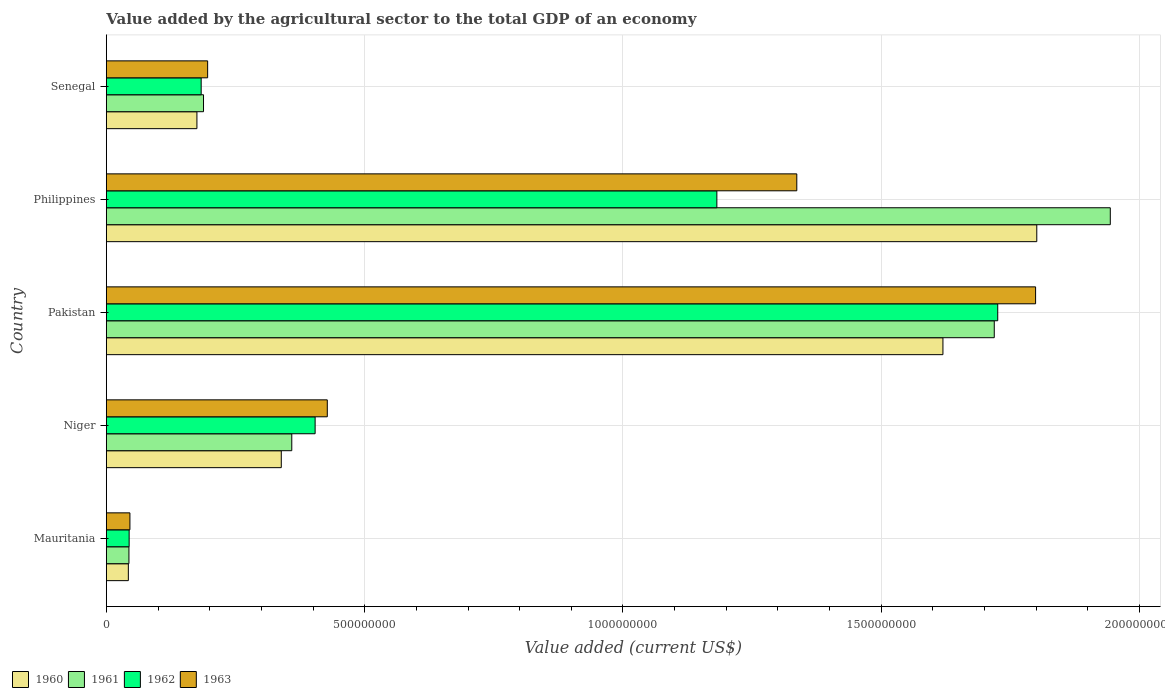How many groups of bars are there?
Provide a short and direct response. 5. Are the number of bars per tick equal to the number of legend labels?
Provide a succinct answer. Yes. What is the value added by the agricultural sector to the total GDP in 1963 in Philippines?
Your response must be concise. 1.34e+09. Across all countries, what is the maximum value added by the agricultural sector to the total GDP in 1960?
Offer a very short reply. 1.80e+09. Across all countries, what is the minimum value added by the agricultural sector to the total GDP in 1960?
Give a very brief answer. 4.26e+07. In which country was the value added by the agricultural sector to the total GDP in 1960 maximum?
Make the answer very short. Philippines. In which country was the value added by the agricultural sector to the total GDP in 1963 minimum?
Provide a short and direct response. Mauritania. What is the total value added by the agricultural sector to the total GDP in 1960 in the graph?
Offer a terse response. 3.98e+09. What is the difference between the value added by the agricultural sector to the total GDP in 1963 in Mauritania and that in Niger?
Provide a succinct answer. -3.82e+08. What is the difference between the value added by the agricultural sector to the total GDP in 1962 in Mauritania and the value added by the agricultural sector to the total GDP in 1963 in Pakistan?
Offer a very short reply. -1.75e+09. What is the average value added by the agricultural sector to the total GDP in 1962 per country?
Offer a very short reply. 7.08e+08. What is the difference between the value added by the agricultural sector to the total GDP in 1960 and value added by the agricultural sector to the total GDP in 1963 in Pakistan?
Keep it short and to the point. -1.79e+08. What is the ratio of the value added by the agricultural sector to the total GDP in 1962 in Mauritania to that in Senegal?
Offer a very short reply. 0.24. What is the difference between the highest and the second highest value added by the agricultural sector to the total GDP in 1961?
Provide a succinct answer. 2.25e+08. What is the difference between the highest and the lowest value added by the agricultural sector to the total GDP in 1960?
Keep it short and to the point. 1.76e+09. In how many countries, is the value added by the agricultural sector to the total GDP in 1960 greater than the average value added by the agricultural sector to the total GDP in 1960 taken over all countries?
Give a very brief answer. 2. Is it the case that in every country, the sum of the value added by the agricultural sector to the total GDP in 1962 and value added by the agricultural sector to the total GDP in 1961 is greater than the sum of value added by the agricultural sector to the total GDP in 1960 and value added by the agricultural sector to the total GDP in 1963?
Make the answer very short. No. Is it the case that in every country, the sum of the value added by the agricultural sector to the total GDP in 1960 and value added by the agricultural sector to the total GDP in 1963 is greater than the value added by the agricultural sector to the total GDP in 1962?
Keep it short and to the point. Yes. How many bars are there?
Your answer should be compact. 20. Does the graph contain any zero values?
Make the answer very short. No. Where does the legend appear in the graph?
Offer a very short reply. Bottom left. How are the legend labels stacked?
Make the answer very short. Horizontal. What is the title of the graph?
Your response must be concise. Value added by the agricultural sector to the total GDP of an economy. Does "2007" appear as one of the legend labels in the graph?
Offer a terse response. No. What is the label or title of the X-axis?
Your answer should be compact. Value added (current US$). What is the label or title of the Y-axis?
Your answer should be compact. Country. What is the Value added (current US$) of 1960 in Mauritania?
Provide a succinct answer. 4.26e+07. What is the Value added (current US$) in 1961 in Mauritania?
Provide a succinct answer. 4.37e+07. What is the Value added (current US$) of 1962 in Mauritania?
Your response must be concise. 4.41e+07. What is the Value added (current US$) in 1963 in Mauritania?
Keep it short and to the point. 4.57e+07. What is the Value added (current US$) of 1960 in Niger?
Provide a short and direct response. 3.39e+08. What is the Value added (current US$) in 1961 in Niger?
Your answer should be compact. 3.59e+08. What is the Value added (current US$) in 1962 in Niger?
Ensure brevity in your answer.  4.04e+08. What is the Value added (current US$) of 1963 in Niger?
Your answer should be compact. 4.28e+08. What is the Value added (current US$) of 1960 in Pakistan?
Offer a very short reply. 1.62e+09. What is the Value added (current US$) of 1961 in Pakistan?
Provide a short and direct response. 1.72e+09. What is the Value added (current US$) of 1962 in Pakistan?
Your answer should be very brief. 1.73e+09. What is the Value added (current US$) in 1963 in Pakistan?
Give a very brief answer. 1.80e+09. What is the Value added (current US$) in 1960 in Philippines?
Make the answer very short. 1.80e+09. What is the Value added (current US$) in 1961 in Philippines?
Your answer should be compact. 1.94e+09. What is the Value added (current US$) of 1962 in Philippines?
Make the answer very short. 1.18e+09. What is the Value added (current US$) of 1963 in Philippines?
Give a very brief answer. 1.34e+09. What is the Value added (current US$) in 1960 in Senegal?
Offer a terse response. 1.75e+08. What is the Value added (current US$) of 1961 in Senegal?
Ensure brevity in your answer.  1.88e+08. What is the Value added (current US$) of 1962 in Senegal?
Provide a short and direct response. 1.84e+08. What is the Value added (current US$) in 1963 in Senegal?
Give a very brief answer. 1.96e+08. Across all countries, what is the maximum Value added (current US$) of 1960?
Provide a short and direct response. 1.80e+09. Across all countries, what is the maximum Value added (current US$) in 1961?
Your response must be concise. 1.94e+09. Across all countries, what is the maximum Value added (current US$) in 1962?
Offer a terse response. 1.73e+09. Across all countries, what is the maximum Value added (current US$) in 1963?
Your answer should be very brief. 1.80e+09. Across all countries, what is the minimum Value added (current US$) in 1960?
Your answer should be compact. 4.26e+07. Across all countries, what is the minimum Value added (current US$) of 1961?
Ensure brevity in your answer.  4.37e+07. Across all countries, what is the minimum Value added (current US$) in 1962?
Provide a short and direct response. 4.41e+07. Across all countries, what is the minimum Value added (current US$) in 1963?
Give a very brief answer. 4.57e+07. What is the total Value added (current US$) of 1960 in the graph?
Provide a short and direct response. 3.98e+09. What is the total Value added (current US$) of 1961 in the graph?
Your answer should be very brief. 4.25e+09. What is the total Value added (current US$) of 1962 in the graph?
Your response must be concise. 3.54e+09. What is the total Value added (current US$) of 1963 in the graph?
Make the answer very short. 3.80e+09. What is the difference between the Value added (current US$) in 1960 in Mauritania and that in Niger?
Your response must be concise. -2.96e+08. What is the difference between the Value added (current US$) in 1961 in Mauritania and that in Niger?
Ensure brevity in your answer.  -3.15e+08. What is the difference between the Value added (current US$) in 1962 in Mauritania and that in Niger?
Keep it short and to the point. -3.60e+08. What is the difference between the Value added (current US$) of 1963 in Mauritania and that in Niger?
Give a very brief answer. -3.82e+08. What is the difference between the Value added (current US$) of 1960 in Mauritania and that in Pakistan?
Keep it short and to the point. -1.58e+09. What is the difference between the Value added (current US$) in 1961 in Mauritania and that in Pakistan?
Your response must be concise. -1.67e+09. What is the difference between the Value added (current US$) of 1962 in Mauritania and that in Pakistan?
Your response must be concise. -1.68e+09. What is the difference between the Value added (current US$) in 1963 in Mauritania and that in Pakistan?
Your answer should be compact. -1.75e+09. What is the difference between the Value added (current US$) of 1960 in Mauritania and that in Philippines?
Make the answer very short. -1.76e+09. What is the difference between the Value added (current US$) in 1961 in Mauritania and that in Philippines?
Keep it short and to the point. -1.90e+09. What is the difference between the Value added (current US$) in 1962 in Mauritania and that in Philippines?
Ensure brevity in your answer.  -1.14e+09. What is the difference between the Value added (current US$) in 1963 in Mauritania and that in Philippines?
Your answer should be compact. -1.29e+09. What is the difference between the Value added (current US$) of 1960 in Mauritania and that in Senegal?
Ensure brevity in your answer.  -1.33e+08. What is the difference between the Value added (current US$) of 1961 in Mauritania and that in Senegal?
Ensure brevity in your answer.  -1.44e+08. What is the difference between the Value added (current US$) in 1962 in Mauritania and that in Senegal?
Ensure brevity in your answer.  -1.39e+08. What is the difference between the Value added (current US$) of 1963 in Mauritania and that in Senegal?
Give a very brief answer. -1.50e+08. What is the difference between the Value added (current US$) in 1960 in Niger and that in Pakistan?
Offer a very short reply. -1.28e+09. What is the difference between the Value added (current US$) in 1961 in Niger and that in Pakistan?
Make the answer very short. -1.36e+09. What is the difference between the Value added (current US$) in 1962 in Niger and that in Pakistan?
Provide a succinct answer. -1.32e+09. What is the difference between the Value added (current US$) in 1963 in Niger and that in Pakistan?
Offer a very short reply. -1.37e+09. What is the difference between the Value added (current US$) of 1960 in Niger and that in Philippines?
Your answer should be compact. -1.46e+09. What is the difference between the Value added (current US$) in 1961 in Niger and that in Philippines?
Your answer should be compact. -1.58e+09. What is the difference between the Value added (current US$) in 1962 in Niger and that in Philippines?
Offer a terse response. -7.78e+08. What is the difference between the Value added (current US$) in 1963 in Niger and that in Philippines?
Give a very brief answer. -9.09e+08. What is the difference between the Value added (current US$) in 1960 in Niger and that in Senegal?
Offer a very short reply. 1.63e+08. What is the difference between the Value added (current US$) of 1961 in Niger and that in Senegal?
Your response must be concise. 1.71e+08. What is the difference between the Value added (current US$) of 1962 in Niger and that in Senegal?
Offer a very short reply. 2.21e+08. What is the difference between the Value added (current US$) of 1963 in Niger and that in Senegal?
Keep it short and to the point. 2.32e+08. What is the difference between the Value added (current US$) in 1960 in Pakistan and that in Philippines?
Keep it short and to the point. -1.82e+08. What is the difference between the Value added (current US$) of 1961 in Pakistan and that in Philippines?
Your answer should be very brief. -2.25e+08. What is the difference between the Value added (current US$) in 1962 in Pakistan and that in Philippines?
Your response must be concise. 5.44e+08. What is the difference between the Value added (current US$) in 1963 in Pakistan and that in Philippines?
Your answer should be compact. 4.62e+08. What is the difference between the Value added (current US$) in 1960 in Pakistan and that in Senegal?
Your response must be concise. 1.44e+09. What is the difference between the Value added (current US$) in 1961 in Pakistan and that in Senegal?
Give a very brief answer. 1.53e+09. What is the difference between the Value added (current US$) in 1962 in Pakistan and that in Senegal?
Offer a very short reply. 1.54e+09. What is the difference between the Value added (current US$) in 1963 in Pakistan and that in Senegal?
Make the answer very short. 1.60e+09. What is the difference between the Value added (current US$) of 1960 in Philippines and that in Senegal?
Provide a short and direct response. 1.63e+09. What is the difference between the Value added (current US$) in 1961 in Philippines and that in Senegal?
Offer a very short reply. 1.76e+09. What is the difference between the Value added (current US$) of 1962 in Philippines and that in Senegal?
Your answer should be compact. 9.98e+08. What is the difference between the Value added (current US$) of 1963 in Philippines and that in Senegal?
Offer a terse response. 1.14e+09. What is the difference between the Value added (current US$) in 1960 in Mauritania and the Value added (current US$) in 1961 in Niger?
Provide a short and direct response. -3.16e+08. What is the difference between the Value added (current US$) of 1960 in Mauritania and the Value added (current US$) of 1962 in Niger?
Your answer should be very brief. -3.62e+08. What is the difference between the Value added (current US$) of 1960 in Mauritania and the Value added (current US$) of 1963 in Niger?
Give a very brief answer. -3.85e+08. What is the difference between the Value added (current US$) in 1961 in Mauritania and the Value added (current US$) in 1962 in Niger?
Offer a very short reply. -3.60e+08. What is the difference between the Value added (current US$) of 1961 in Mauritania and the Value added (current US$) of 1963 in Niger?
Your answer should be compact. -3.84e+08. What is the difference between the Value added (current US$) in 1962 in Mauritania and the Value added (current US$) in 1963 in Niger?
Your answer should be compact. -3.84e+08. What is the difference between the Value added (current US$) in 1960 in Mauritania and the Value added (current US$) in 1961 in Pakistan?
Your response must be concise. -1.68e+09. What is the difference between the Value added (current US$) in 1960 in Mauritania and the Value added (current US$) in 1962 in Pakistan?
Provide a short and direct response. -1.68e+09. What is the difference between the Value added (current US$) in 1960 in Mauritania and the Value added (current US$) in 1963 in Pakistan?
Provide a succinct answer. -1.76e+09. What is the difference between the Value added (current US$) of 1961 in Mauritania and the Value added (current US$) of 1962 in Pakistan?
Provide a short and direct response. -1.68e+09. What is the difference between the Value added (current US$) of 1961 in Mauritania and the Value added (current US$) of 1963 in Pakistan?
Make the answer very short. -1.75e+09. What is the difference between the Value added (current US$) of 1962 in Mauritania and the Value added (current US$) of 1963 in Pakistan?
Your answer should be compact. -1.75e+09. What is the difference between the Value added (current US$) of 1960 in Mauritania and the Value added (current US$) of 1961 in Philippines?
Provide a succinct answer. -1.90e+09. What is the difference between the Value added (current US$) in 1960 in Mauritania and the Value added (current US$) in 1962 in Philippines?
Give a very brief answer. -1.14e+09. What is the difference between the Value added (current US$) of 1960 in Mauritania and the Value added (current US$) of 1963 in Philippines?
Your answer should be compact. -1.29e+09. What is the difference between the Value added (current US$) in 1961 in Mauritania and the Value added (current US$) in 1962 in Philippines?
Offer a terse response. -1.14e+09. What is the difference between the Value added (current US$) in 1961 in Mauritania and the Value added (current US$) in 1963 in Philippines?
Your response must be concise. -1.29e+09. What is the difference between the Value added (current US$) in 1962 in Mauritania and the Value added (current US$) in 1963 in Philippines?
Offer a terse response. -1.29e+09. What is the difference between the Value added (current US$) in 1960 in Mauritania and the Value added (current US$) in 1961 in Senegal?
Your answer should be very brief. -1.46e+08. What is the difference between the Value added (current US$) of 1960 in Mauritania and the Value added (current US$) of 1962 in Senegal?
Make the answer very short. -1.41e+08. What is the difference between the Value added (current US$) of 1960 in Mauritania and the Value added (current US$) of 1963 in Senegal?
Offer a terse response. -1.53e+08. What is the difference between the Value added (current US$) of 1961 in Mauritania and the Value added (current US$) of 1962 in Senegal?
Keep it short and to the point. -1.40e+08. What is the difference between the Value added (current US$) in 1961 in Mauritania and the Value added (current US$) in 1963 in Senegal?
Your answer should be compact. -1.52e+08. What is the difference between the Value added (current US$) in 1962 in Mauritania and the Value added (current US$) in 1963 in Senegal?
Provide a short and direct response. -1.52e+08. What is the difference between the Value added (current US$) in 1960 in Niger and the Value added (current US$) in 1961 in Pakistan?
Give a very brief answer. -1.38e+09. What is the difference between the Value added (current US$) of 1960 in Niger and the Value added (current US$) of 1962 in Pakistan?
Your answer should be compact. -1.39e+09. What is the difference between the Value added (current US$) of 1960 in Niger and the Value added (current US$) of 1963 in Pakistan?
Your answer should be compact. -1.46e+09. What is the difference between the Value added (current US$) in 1961 in Niger and the Value added (current US$) in 1962 in Pakistan?
Offer a terse response. -1.37e+09. What is the difference between the Value added (current US$) of 1961 in Niger and the Value added (current US$) of 1963 in Pakistan?
Provide a succinct answer. -1.44e+09. What is the difference between the Value added (current US$) of 1962 in Niger and the Value added (current US$) of 1963 in Pakistan?
Your answer should be compact. -1.39e+09. What is the difference between the Value added (current US$) of 1960 in Niger and the Value added (current US$) of 1961 in Philippines?
Provide a short and direct response. -1.60e+09. What is the difference between the Value added (current US$) of 1960 in Niger and the Value added (current US$) of 1962 in Philippines?
Your response must be concise. -8.43e+08. What is the difference between the Value added (current US$) in 1960 in Niger and the Value added (current US$) in 1963 in Philippines?
Make the answer very short. -9.98e+08. What is the difference between the Value added (current US$) of 1961 in Niger and the Value added (current US$) of 1962 in Philippines?
Offer a very short reply. -8.23e+08. What is the difference between the Value added (current US$) of 1961 in Niger and the Value added (current US$) of 1963 in Philippines?
Your response must be concise. -9.77e+08. What is the difference between the Value added (current US$) of 1962 in Niger and the Value added (current US$) of 1963 in Philippines?
Offer a very short reply. -9.32e+08. What is the difference between the Value added (current US$) in 1960 in Niger and the Value added (current US$) in 1961 in Senegal?
Provide a succinct answer. 1.50e+08. What is the difference between the Value added (current US$) of 1960 in Niger and the Value added (current US$) of 1962 in Senegal?
Make the answer very short. 1.55e+08. What is the difference between the Value added (current US$) of 1960 in Niger and the Value added (current US$) of 1963 in Senegal?
Your response must be concise. 1.43e+08. What is the difference between the Value added (current US$) of 1961 in Niger and the Value added (current US$) of 1962 in Senegal?
Give a very brief answer. 1.75e+08. What is the difference between the Value added (current US$) in 1961 in Niger and the Value added (current US$) in 1963 in Senegal?
Provide a succinct answer. 1.63e+08. What is the difference between the Value added (current US$) of 1962 in Niger and the Value added (current US$) of 1963 in Senegal?
Your response must be concise. 2.08e+08. What is the difference between the Value added (current US$) of 1960 in Pakistan and the Value added (current US$) of 1961 in Philippines?
Your response must be concise. -3.24e+08. What is the difference between the Value added (current US$) in 1960 in Pakistan and the Value added (current US$) in 1962 in Philippines?
Make the answer very short. 4.38e+08. What is the difference between the Value added (current US$) in 1960 in Pakistan and the Value added (current US$) in 1963 in Philippines?
Your response must be concise. 2.83e+08. What is the difference between the Value added (current US$) of 1961 in Pakistan and the Value added (current US$) of 1962 in Philippines?
Provide a succinct answer. 5.37e+08. What is the difference between the Value added (current US$) of 1961 in Pakistan and the Value added (current US$) of 1963 in Philippines?
Make the answer very short. 3.82e+08. What is the difference between the Value added (current US$) of 1962 in Pakistan and the Value added (current US$) of 1963 in Philippines?
Keep it short and to the point. 3.89e+08. What is the difference between the Value added (current US$) of 1960 in Pakistan and the Value added (current US$) of 1961 in Senegal?
Offer a terse response. 1.43e+09. What is the difference between the Value added (current US$) of 1960 in Pakistan and the Value added (current US$) of 1962 in Senegal?
Provide a succinct answer. 1.44e+09. What is the difference between the Value added (current US$) in 1960 in Pakistan and the Value added (current US$) in 1963 in Senegal?
Offer a terse response. 1.42e+09. What is the difference between the Value added (current US$) of 1961 in Pakistan and the Value added (current US$) of 1962 in Senegal?
Make the answer very short. 1.54e+09. What is the difference between the Value added (current US$) in 1961 in Pakistan and the Value added (current US$) in 1963 in Senegal?
Provide a short and direct response. 1.52e+09. What is the difference between the Value added (current US$) of 1962 in Pakistan and the Value added (current US$) of 1963 in Senegal?
Keep it short and to the point. 1.53e+09. What is the difference between the Value added (current US$) in 1960 in Philippines and the Value added (current US$) in 1961 in Senegal?
Offer a very short reply. 1.61e+09. What is the difference between the Value added (current US$) of 1960 in Philippines and the Value added (current US$) of 1962 in Senegal?
Provide a short and direct response. 1.62e+09. What is the difference between the Value added (current US$) of 1960 in Philippines and the Value added (current US$) of 1963 in Senegal?
Offer a very short reply. 1.60e+09. What is the difference between the Value added (current US$) in 1961 in Philippines and the Value added (current US$) in 1962 in Senegal?
Offer a very short reply. 1.76e+09. What is the difference between the Value added (current US$) in 1961 in Philippines and the Value added (current US$) in 1963 in Senegal?
Your answer should be compact. 1.75e+09. What is the difference between the Value added (current US$) of 1962 in Philippines and the Value added (current US$) of 1963 in Senegal?
Keep it short and to the point. 9.86e+08. What is the average Value added (current US$) in 1960 per country?
Your answer should be very brief. 7.95e+08. What is the average Value added (current US$) in 1961 per country?
Provide a short and direct response. 8.51e+08. What is the average Value added (current US$) in 1962 per country?
Your answer should be compact. 7.08e+08. What is the average Value added (current US$) of 1963 per country?
Offer a terse response. 7.61e+08. What is the difference between the Value added (current US$) in 1960 and Value added (current US$) in 1961 in Mauritania?
Keep it short and to the point. -1.15e+06. What is the difference between the Value added (current US$) of 1960 and Value added (current US$) of 1962 in Mauritania?
Offer a very short reply. -1.54e+06. What is the difference between the Value added (current US$) of 1960 and Value added (current US$) of 1963 in Mauritania?
Offer a very short reply. -3.07e+06. What is the difference between the Value added (current US$) of 1961 and Value added (current US$) of 1962 in Mauritania?
Keep it short and to the point. -3.84e+05. What is the difference between the Value added (current US$) in 1961 and Value added (current US$) in 1963 in Mauritania?
Your answer should be very brief. -1.92e+06. What is the difference between the Value added (current US$) in 1962 and Value added (current US$) in 1963 in Mauritania?
Provide a succinct answer. -1.54e+06. What is the difference between the Value added (current US$) of 1960 and Value added (current US$) of 1961 in Niger?
Make the answer very short. -2.03e+07. What is the difference between the Value added (current US$) of 1960 and Value added (current US$) of 1962 in Niger?
Offer a very short reply. -6.55e+07. What is the difference between the Value added (current US$) of 1960 and Value added (current US$) of 1963 in Niger?
Offer a very short reply. -8.91e+07. What is the difference between the Value added (current US$) of 1961 and Value added (current US$) of 1962 in Niger?
Offer a terse response. -4.52e+07. What is the difference between the Value added (current US$) of 1961 and Value added (current US$) of 1963 in Niger?
Your answer should be very brief. -6.88e+07. What is the difference between the Value added (current US$) in 1962 and Value added (current US$) in 1963 in Niger?
Provide a succinct answer. -2.36e+07. What is the difference between the Value added (current US$) in 1960 and Value added (current US$) in 1961 in Pakistan?
Your answer should be compact. -9.93e+07. What is the difference between the Value added (current US$) of 1960 and Value added (current US$) of 1962 in Pakistan?
Ensure brevity in your answer.  -1.06e+08. What is the difference between the Value added (current US$) of 1960 and Value added (current US$) of 1963 in Pakistan?
Your answer should be compact. -1.79e+08. What is the difference between the Value added (current US$) in 1961 and Value added (current US$) in 1962 in Pakistan?
Ensure brevity in your answer.  -6.72e+06. What is the difference between the Value added (current US$) of 1961 and Value added (current US$) of 1963 in Pakistan?
Keep it short and to the point. -8.00e+07. What is the difference between the Value added (current US$) in 1962 and Value added (current US$) in 1963 in Pakistan?
Keep it short and to the point. -7.33e+07. What is the difference between the Value added (current US$) of 1960 and Value added (current US$) of 1961 in Philippines?
Make the answer very short. -1.42e+08. What is the difference between the Value added (current US$) in 1960 and Value added (current US$) in 1962 in Philippines?
Your answer should be compact. 6.19e+08. What is the difference between the Value added (current US$) of 1960 and Value added (current US$) of 1963 in Philippines?
Offer a very short reply. 4.64e+08. What is the difference between the Value added (current US$) of 1961 and Value added (current US$) of 1962 in Philippines?
Give a very brief answer. 7.61e+08. What is the difference between the Value added (current US$) of 1961 and Value added (current US$) of 1963 in Philippines?
Provide a succinct answer. 6.07e+08. What is the difference between the Value added (current US$) in 1962 and Value added (current US$) in 1963 in Philippines?
Offer a terse response. -1.55e+08. What is the difference between the Value added (current US$) of 1960 and Value added (current US$) of 1961 in Senegal?
Offer a very short reply. -1.28e+07. What is the difference between the Value added (current US$) of 1960 and Value added (current US$) of 1962 in Senegal?
Provide a short and direct response. -8.24e+06. What is the difference between the Value added (current US$) of 1960 and Value added (current US$) of 1963 in Senegal?
Provide a succinct answer. -2.07e+07. What is the difference between the Value added (current US$) of 1961 and Value added (current US$) of 1962 in Senegal?
Your answer should be very brief. 4.54e+06. What is the difference between the Value added (current US$) of 1961 and Value added (current US$) of 1963 in Senegal?
Ensure brevity in your answer.  -7.96e+06. What is the difference between the Value added (current US$) of 1962 and Value added (current US$) of 1963 in Senegal?
Provide a succinct answer. -1.25e+07. What is the ratio of the Value added (current US$) of 1960 in Mauritania to that in Niger?
Your response must be concise. 0.13. What is the ratio of the Value added (current US$) of 1961 in Mauritania to that in Niger?
Offer a terse response. 0.12. What is the ratio of the Value added (current US$) of 1962 in Mauritania to that in Niger?
Provide a succinct answer. 0.11. What is the ratio of the Value added (current US$) of 1963 in Mauritania to that in Niger?
Give a very brief answer. 0.11. What is the ratio of the Value added (current US$) in 1960 in Mauritania to that in Pakistan?
Provide a succinct answer. 0.03. What is the ratio of the Value added (current US$) of 1961 in Mauritania to that in Pakistan?
Your answer should be compact. 0.03. What is the ratio of the Value added (current US$) of 1962 in Mauritania to that in Pakistan?
Ensure brevity in your answer.  0.03. What is the ratio of the Value added (current US$) in 1963 in Mauritania to that in Pakistan?
Your answer should be very brief. 0.03. What is the ratio of the Value added (current US$) of 1960 in Mauritania to that in Philippines?
Keep it short and to the point. 0.02. What is the ratio of the Value added (current US$) of 1961 in Mauritania to that in Philippines?
Your response must be concise. 0.02. What is the ratio of the Value added (current US$) of 1962 in Mauritania to that in Philippines?
Make the answer very short. 0.04. What is the ratio of the Value added (current US$) of 1963 in Mauritania to that in Philippines?
Make the answer very short. 0.03. What is the ratio of the Value added (current US$) of 1960 in Mauritania to that in Senegal?
Your answer should be very brief. 0.24. What is the ratio of the Value added (current US$) in 1961 in Mauritania to that in Senegal?
Your answer should be very brief. 0.23. What is the ratio of the Value added (current US$) in 1962 in Mauritania to that in Senegal?
Ensure brevity in your answer.  0.24. What is the ratio of the Value added (current US$) in 1963 in Mauritania to that in Senegal?
Your response must be concise. 0.23. What is the ratio of the Value added (current US$) of 1960 in Niger to that in Pakistan?
Provide a short and direct response. 0.21. What is the ratio of the Value added (current US$) in 1961 in Niger to that in Pakistan?
Your answer should be compact. 0.21. What is the ratio of the Value added (current US$) in 1962 in Niger to that in Pakistan?
Offer a very short reply. 0.23. What is the ratio of the Value added (current US$) in 1963 in Niger to that in Pakistan?
Make the answer very short. 0.24. What is the ratio of the Value added (current US$) of 1960 in Niger to that in Philippines?
Your response must be concise. 0.19. What is the ratio of the Value added (current US$) in 1961 in Niger to that in Philippines?
Your answer should be compact. 0.18. What is the ratio of the Value added (current US$) in 1962 in Niger to that in Philippines?
Offer a very short reply. 0.34. What is the ratio of the Value added (current US$) of 1963 in Niger to that in Philippines?
Your response must be concise. 0.32. What is the ratio of the Value added (current US$) in 1960 in Niger to that in Senegal?
Your answer should be compact. 1.93. What is the ratio of the Value added (current US$) of 1961 in Niger to that in Senegal?
Make the answer very short. 1.91. What is the ratio of the Value added (current US$) of 1962 in Niger to that in Senegal?
Offer a very short reply. 2.2. What is the ratio of the Value added (current US$) of 1963 in Niger to that in Senegal?
Give a very brief answer. 2.18. What is the ratio of the Value added (current US$) in 1960 in Pakistan to that in Philippines?
Provide a short and direct response. 0.9. What is the ratio of the Value added (current US$) in 1961 in Pakistan to that in Philippines?
Ensure brevity in your answer.  0.88. What is the ratio of the Value added (current US$) of 1962 in Pakistan to that in Philippines?
Ensure brevity in your answer.  1.46. What is the ratio of the Value added (current US$) of 1963 in Pakistan to that in Philippines?
Offer a very short reply. 1.35. What is the ratio of the Value added (current US$) of 1960 in Pakistan to that in Senegal?
Your response must be concise. 9.24. What is the ratio of the Value added (current US$) of 1961 in Pakistan to that in Senegal?
Provide a succinct answer. 9.14. What is the ratio of the Value added (current US$) in 1962 in Pakistan to that in Senegal?
Your answer should be very brief. 9.4. What is the ratio of the Value added (current US$) in 1963 in Pakistan to that in Senegal?
Keep it short and to the point. 9.17. What is the ratio of the Value added (current US$) in 1960 in Philippines to that in Senegal?
Ensure brevity in your answer.  10.27. What is the ratio of the Value added (current US$) of 1961 in Philippines to that in Senegal?
Your answer should be compact. 10.33. What is the ratio of the Value added (current US$) in 1962 in Philippines to that in Senegal?
Ensure brevity in your answer.  6.44. What is the ratio of the Value added (current US$) of 1963 in Philippines to that in Senegal?
Provide a short and direct response. 6.82. What is the difference between the highest and the second highest Value added (current US$) of 1960?
Your answer should be compact. 1.82e+08. What is the difference between the highest and the second highest Value added (current US$) of 1961?
Keep it short and to the point. 2.25e+08. What is the difference between the highest and the second highest Value added (current US$) in 1962?
Ensure brevity in your answer.  5.44e+08. What is the difference between the highest and the second highest Value added (current US$) of 1963?
Your response must be concise. 4.62e+08. What is the difference between the highest and the lowest Value added (current US$) of 1960?
Your answer should be very brief. 1.76e+09. What is the difference between the highest and the lowest Value added (current US$) of 1961?
Your answer should be compact. 1.90e+09. What is the difference between the highest and the lowest Value added (current US$) of 1962?
Provide a succinct answer. 1.68e+09. What is the difference between the highest and the lowest Value added (current US$) of 1963?
Your response must be concise. 1.75e+09. 